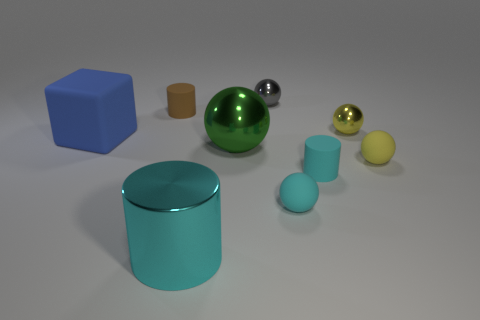What color is the big ball?
Offer a very short reply. Green. Is the color of the large metallic thing that is in front of the green object the same as the sphere that is on the left side of the tiny gray metallic ball?
Provide a short and direct response. No. The gray thing that is the same shape as the small yellow matte object is what size?
Offer a terse response. Small. Is there a big metallic thing that has the same color as the big ball?
Give a very brief answer. No. What is the material of the other cylinder that is the same color as the shiny cylinder?
Provide a succinct answer. Rubber. How many tiny balls have the same color as the large rubber cube?
Your response must be concise. 0. How many things are either metallic objects in front of the blue matte block or green objects?
Your response must be concise. 2. There is a large cube that is the same material as the tiny brown cylinder; what color is it?
Keep it short and to the point. Blue. Is there a blue matte cube that has the same size as the yellow metallic thing?
Offer a very short reply. No. What number of things are objects that are on the right side of the large green metal thing or things that are in front of the big metallic sphere?
Ensure brevity in your answer.  6. 